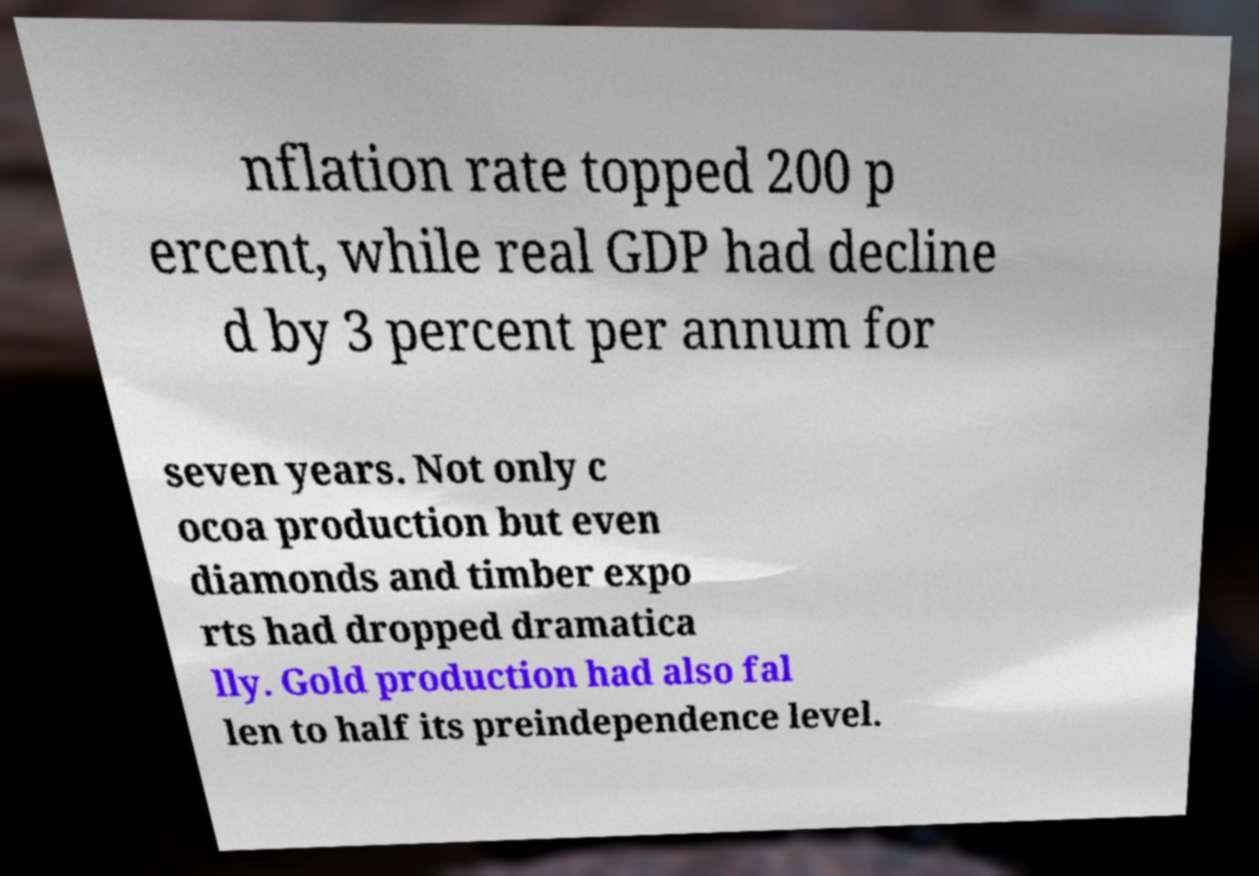Could you assist in decoding the text presented in this image and type it out clearly? nflation rate topped 200 p ercent, while real GDP had decline d by 3 percent per annum for seven years. Not only c ocoa production but even diamonds and timber expo rts had dropped dramatica lly. Gold production had also fal len to half its preindependence level. 